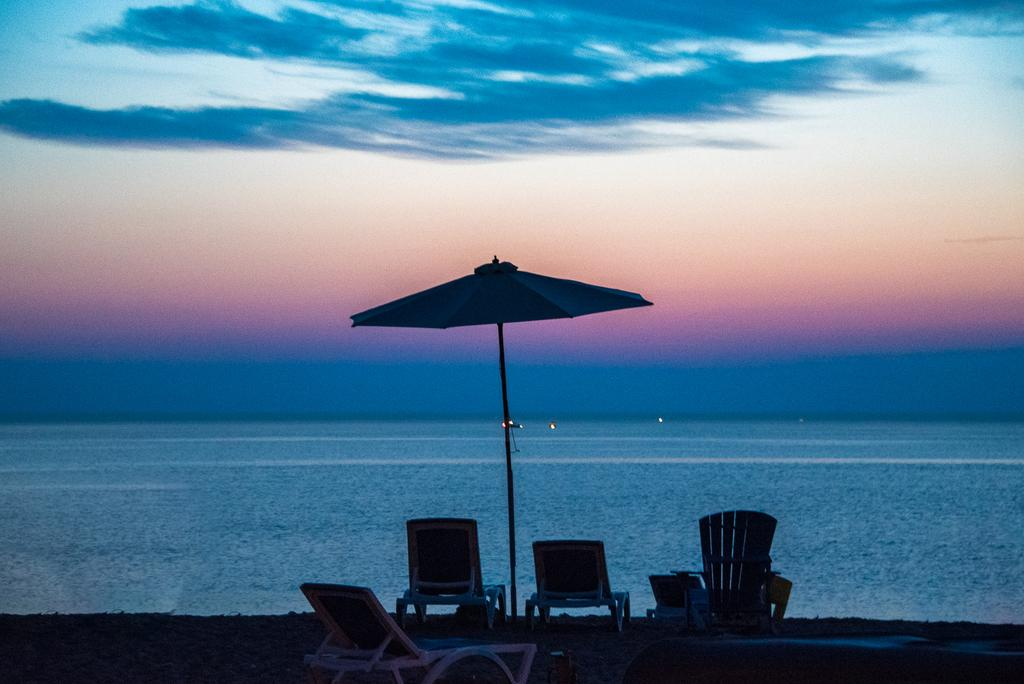What type of furniture is present in the image? There are chairs in the image. What object is used for protection from the sun or rain in the image? There is an umbrella in the image. What natural element is visible in the background of the image? The background of the image includes water. What part of the natural environment is visible in the image? The sky is visible in the image. What colors can be seen in the sky in the image? The colors of the sky are blue, white, and orange. What type of cloth is used to mark the territory in the image? There is no cloth or territory marking present in the image. What type of frame is holding the umbrella in the image? The umbrella in the image does not have a frame; it is a standalone object. 